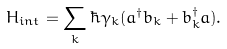<formula> <loc_0><loc_0><loc_500><loc_500>H _ { i n t } = \sum _ { k } \hbar { \gamma } _ { k } ( a ^ { \dagger } b _ { k } + b _ { k } ^ { \dagger } a ) .</formula> 